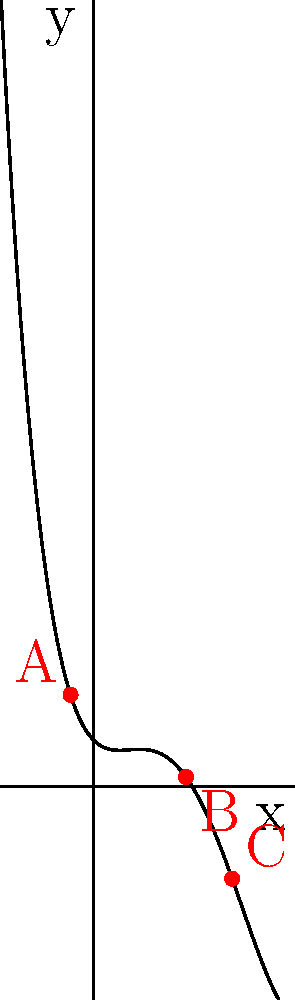In the graph above, which represents a polynomial function resembling a dramatic character arc, identify the number and nature of the turning points. How do these points relate to the potential plot twists in a script? To answer this question, let's analyze the graph step-by-step:

1) First, we need to identify the turning points. These are the points where the function changes from increasing to decreasing or vice versa.

2) From the graph, we can see three critical points labeled A, B, and C.

3) Point A is a local maximum. This could represent a high point in the character's journey, perhaps an initial success or moment of triumph.

4) Point B is a local minimum. This might symbolize a low point for the character, a moment of failure or despair.

5) Point C is another local maximum. This could represent a final triumph or resolution for the character.

6) The nature of these turning points:
   - A is a maximum (the curve changes from increasing to decreasing)
   - B is a minimum (the curve changes from decreasing to increasing)
   - C is a maximum (the curve changes from increasing to decreasing)

7) In terms of plot twists:
   - The descent from A to B could represent a fall from grace or a series of challenges.
   - The rise from B to C could represent the character's journey to overcome these challenges.
   - The final descent after C could represent a denouement or resolution.

This polynomial has two maxima and one minimum, which could represent a complex character arc with multiple highs and lows, much like a well-crafted dramatic script.
Answer: 3 turning points: 2 maxima (A, C) and 1 minimum (B), representing major plot twists in a dramatic arc. 